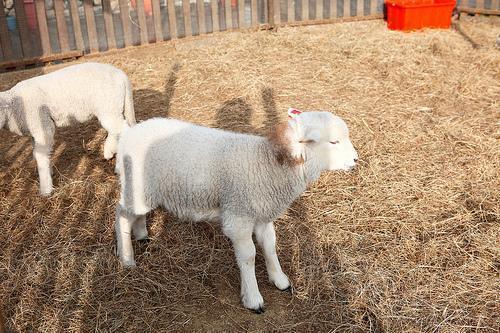How many sheep in the picture re looking to the right?
Give a very brief answer. 1. How many faces do you see in the picture?
Give a very brief answer. 1. 